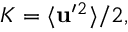Convert formula to latex. <formula><loc_0><loc_0><loc_500><loc_500>K = \langle { { u } ^ { \prime ^ { 2 } } \rangle / 2 ,</formula> 